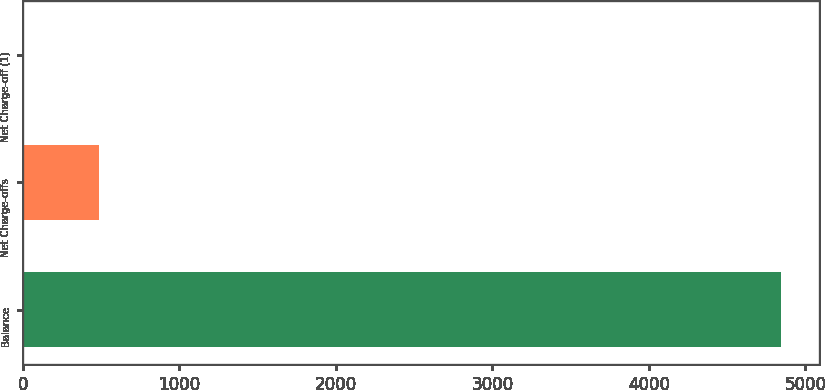Convert chart. <chart><loc_0><loc_0><loc_500><loc_500><bar_chart><fcel>Balance<fcel>Net Charge-offs<fcel>Net Charge-off (1)<nl><fcel>4846<fcel>486.14<fcel>1.71<nl></chart> 